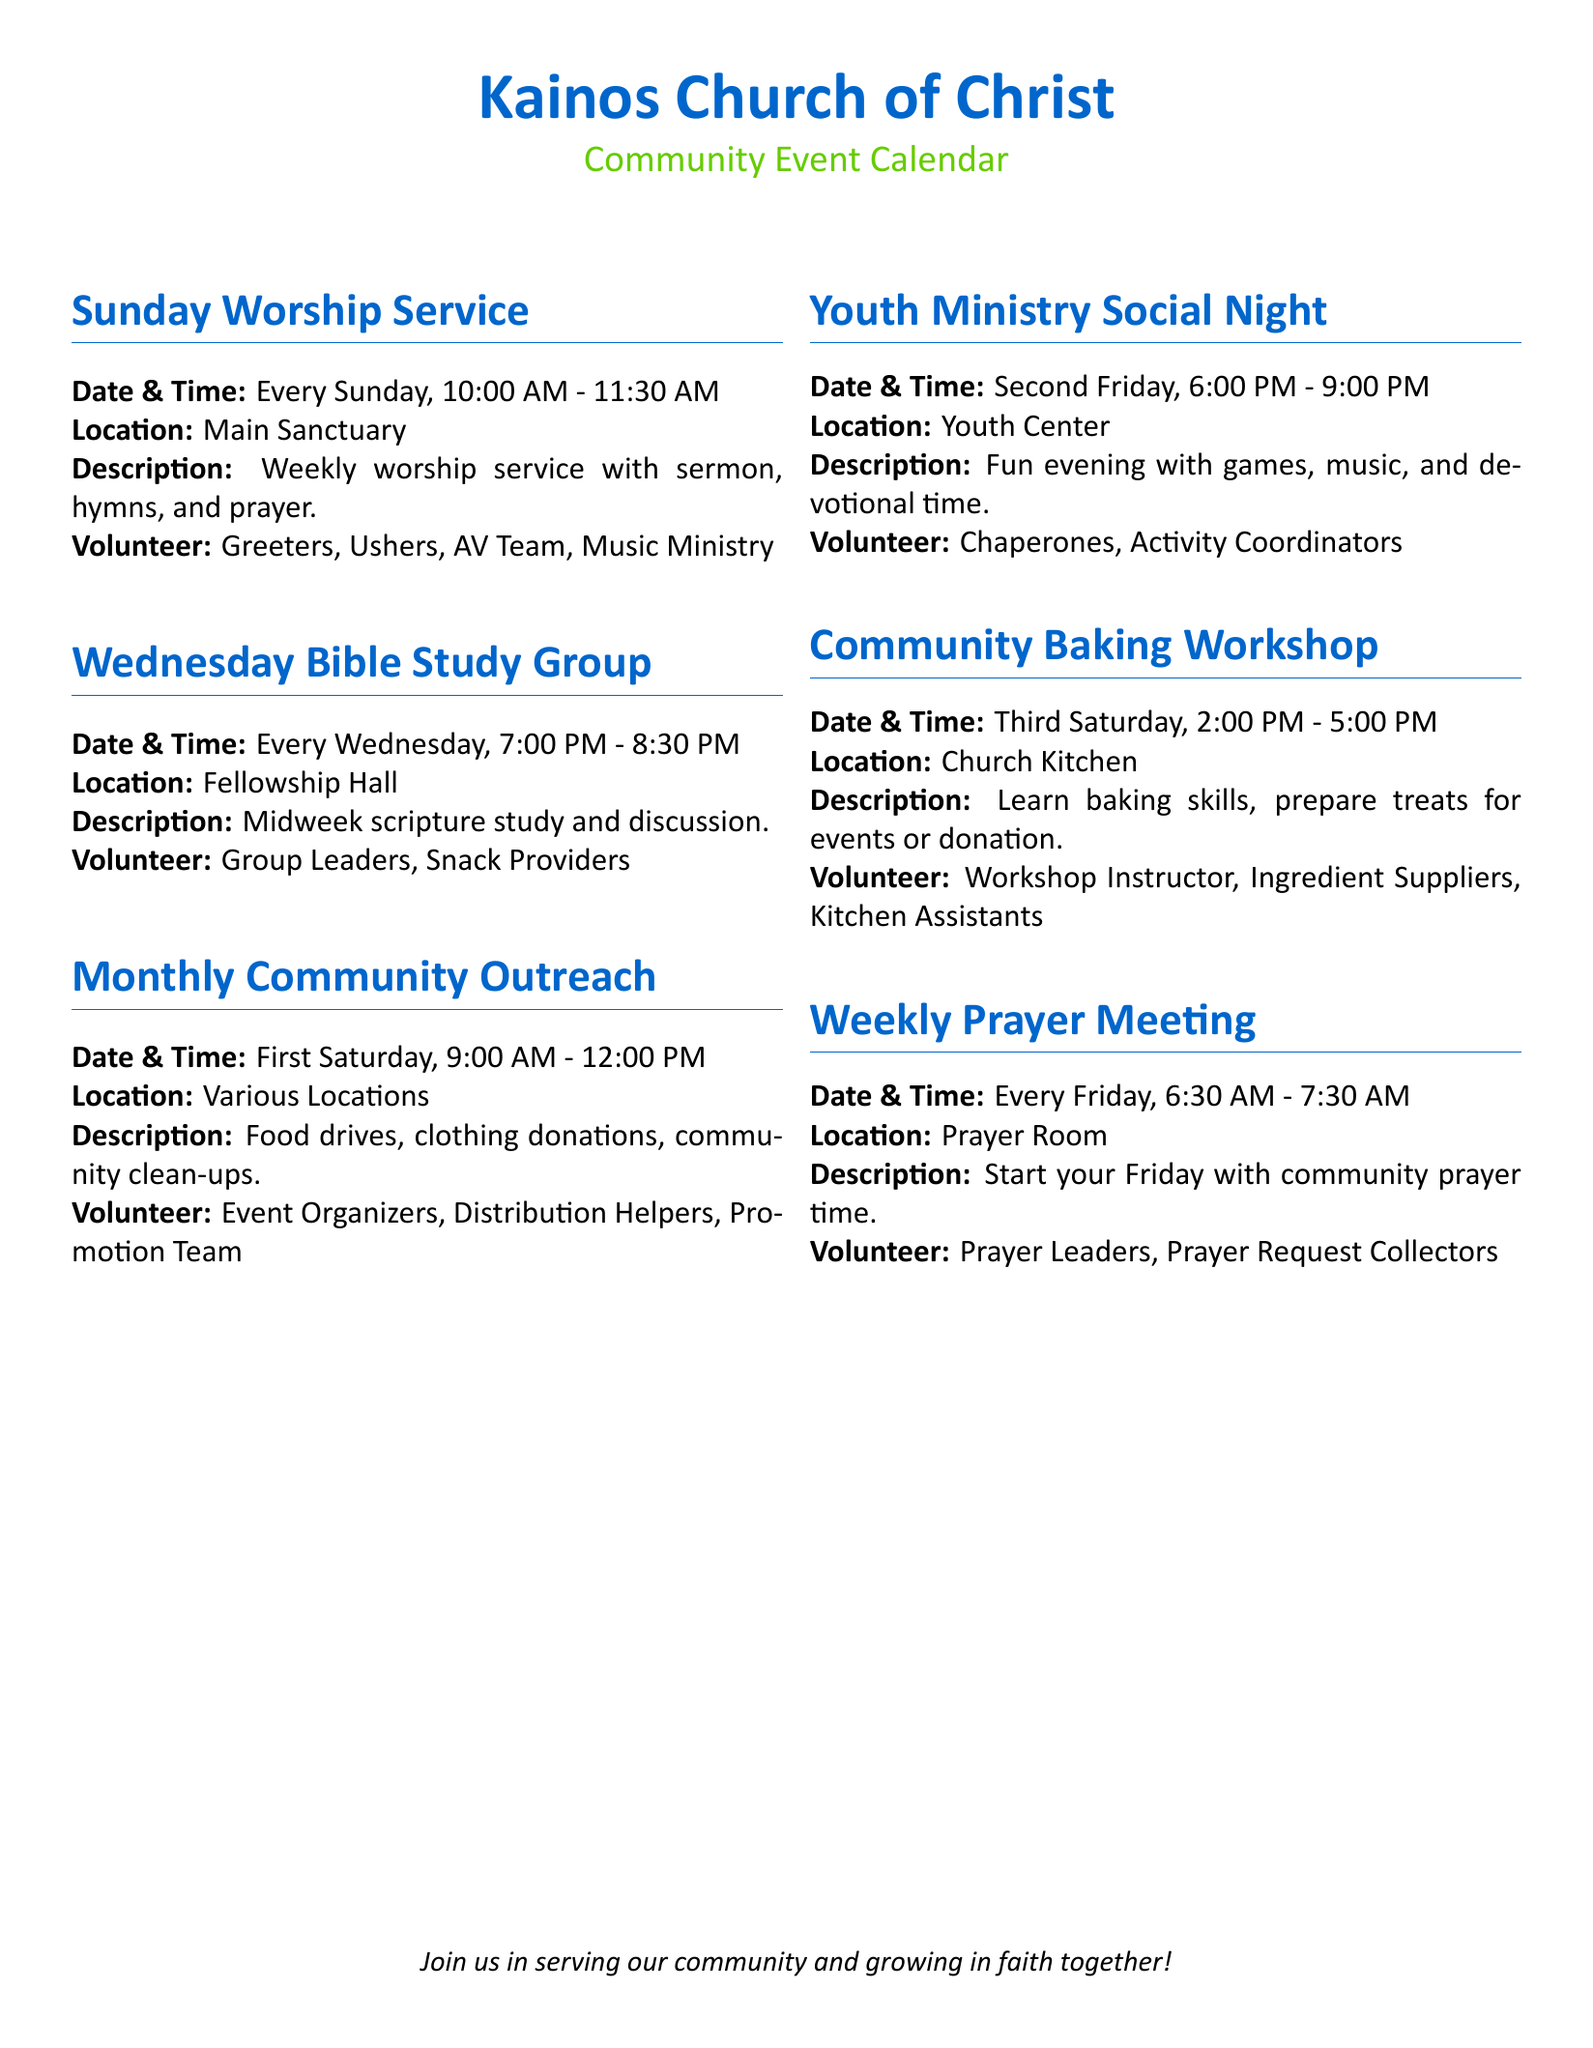What is the time of the Sunday Worship Service? The Sunday Worship Service starts at 10:00 AM and ends at 11:30 AM.
Answer: 10:00 AM - 11:30 AM On which day does the Monthly Community Outreach occur? The Monthly Community Outreach takes place on the first Saturday of each month.
Answer: First Saturday What is the location of the Community Baking Workshop? The Community Baking Workshop is held in the Church Kitchen.
Answer: Church Kitchen Who are the volunteers needed for the Youth Ministry Social Night? Volunteers for the Youth Ministry Social Night include chaperones and activity coordinators.
Answer: Chaperones, Activity Coordinators How often does the Weekly Prayer Meeting occur? The Weekly Prayer Meeting is scheduled every Friday.
Answer: Every Friday What type of activities are included in the Monthly Community Outreach? The Monthly Community Outreach involves food drives, clothing donations, and community clean-ups.
Answer: Food drives, clothing donations, community clean-ups What is the main focus of the Community Baking Workshop? The Community Baking Workshop focuses on learning baking skills and preparing treats.
Answer: Learning baking skills, preparing treats How long does the Wednesday Bible Study Group last? The Wednesday Bible Study Group lasts for 1.5 hours, from 7:00 PM to 8:30 PM.
Answer: 1.5 hours 